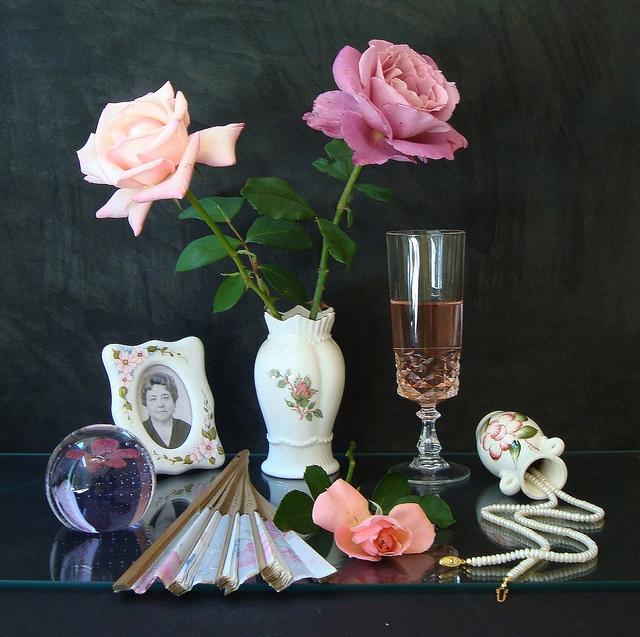Would this work for a boy's room?
Short answer required. No. What is the theme of this collection?
Concise answer only. Roses. What kind of necklace is in this picture?
Keep it brief. Pearl. 